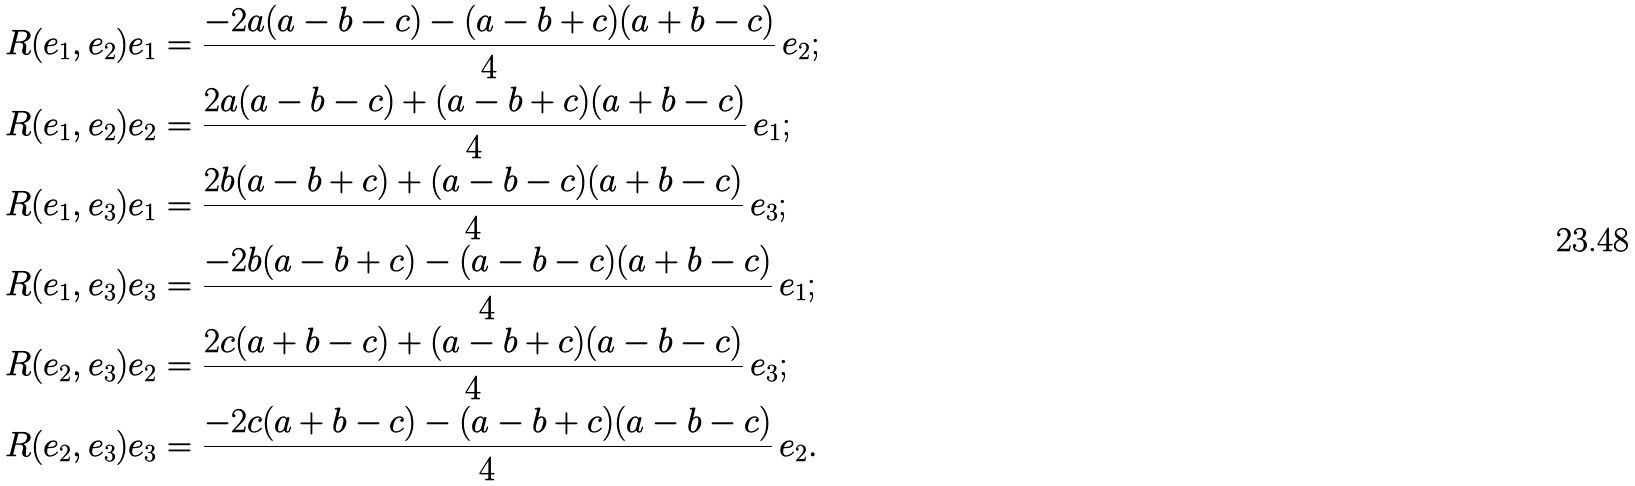<formula> <loc_0><loc_0><loc_500><loc_500>R ( e _ { 1 } , e _ { 2 } ) e _ { 1 } & = \frac { - 2 a ( a - b - c ) - ( a - b + c ) ( a + b - c ) } { 4 } \, e _ { 2 } ; \\ R ( e _ { 1 } , e _ { 2 } ) e _ { 2 } & = \frac { 2 a ( a - b - c ) + ( a - b + c ) ( a + b - c ) } { 4 } \, e _ { 1 } ; \\ R ( e _ { 1 } , e _ { 3 } ) e _ { 1 } & = \frac { 2 b ( a - b + c ) + ( a - b - c ) ( a + b - c ) } { 4 } \, e _ { 3 } ; \\ R ( e _ { 1 } , e _ { 3 } ) e _ { 3 } & = \frac { - 2 b ( a - b + c ) - ( a - b - c ) ( a + b - c ) } { 4 } \, e _ { 1 } ; \\ R ( e _ { 2 } , e _ { 3 } ) e _ { 2 } & = \frac { 2 c ( a + b - c ) + ( a - b + c ) ( a - b - c ) } { 4 } \, e _ { 3 } ; \\ R ( e _ { 2 } , e _ { 3 } ) e _ { 3 } & = \frac { - 2 c ( a + b - c ) - ( a - b + c ) ( a - b - c ) } { 4 } \, e _ { 2 } .</formula> 